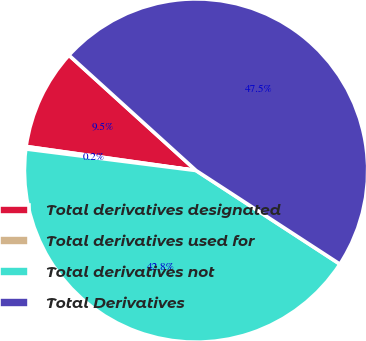Convert chart. <chart><loc_0><loc_0><loc_500><loc_500><pie_chart><fcel>Total derivatives designated<fcel>Total derivatives used for<fcel>Total derivatives not<fcel>Total Derivatives<nl><fcel>9.49%<fcel>0.23%<fcel>42.82%<fcel>47.45%<nl></chart> 